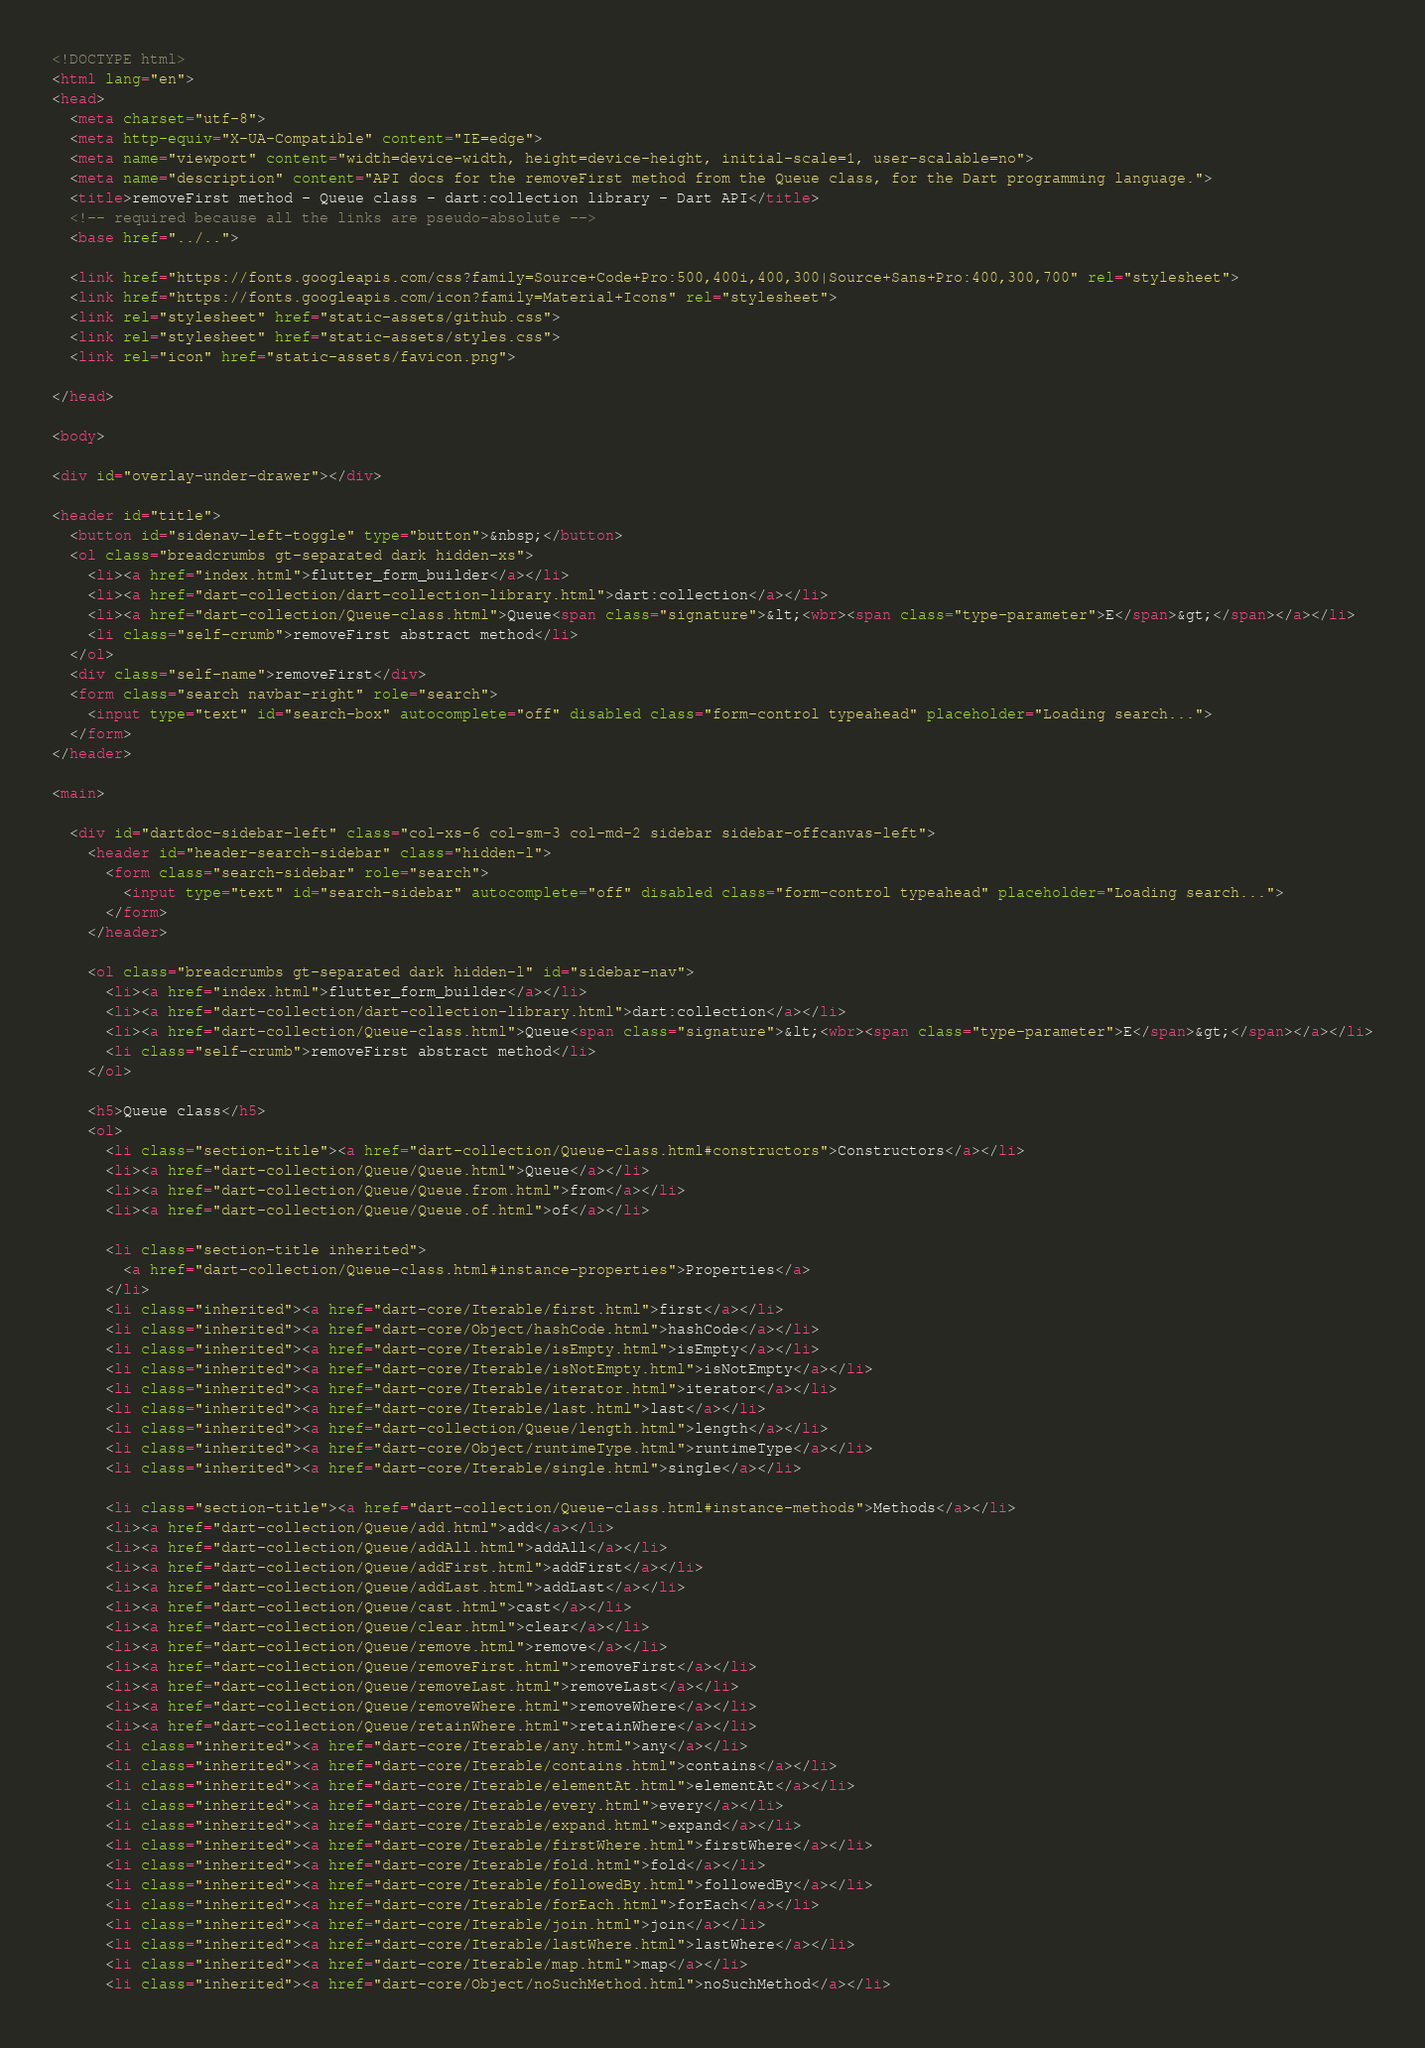Convert code to text. <code><loc_0><loc_0><loc_500><loc_500><_HTML_><!DOCTYPE html>
<html lang="en">
<head>
  <meta charset="utf-8">
  <meta http-equiv="X-UA-Compatible" content="IE=edge">
  <meta name="viewport" content="width=device-width, height=device-height, initial-scale=1, user-scalable=no">
  <meta name="description" content="API docs for the removeFirst method from the Queue class, for the Dart programming language.">
  <title>removeFirst method - Queue class - dart:collection library - Dart API</title>
  <!-- required because all the links are pseudo-absolute -->
  <base href="../..">

  <link href="https://fonts.googleapis.com/css?family=Source+Code+Pro:500,400i,400,300|Source+Sans+Pro:400,300,700" rel="stylesheet">
  <link href="https://fonts.googleapis.com/icon?family=Material+Icons" rel="stylesheet">
  <link rel="stylesheet" href="static-assets/github.css">
  <link rel="stylesheet" href="static-assets/styles.css">
  <link rel="icon" href="static-assets/favicon.png">
  
</head>

<body>

<div id="overlay-under-drawer"></div>

<header id="title">
  <button id="sidenav-left-toggle" type="button">&nbsp;</button>
  <ol class="breadcrumbs gt-separated dark hidden-xs">
    <li><a href="index.html">flutter_form_builder</a></li>
    <li><a href="dart-collection/dart-collection-library.html">dart:collection</a></li>
    <li><a href="dart-collection/Queue-class.html">Queue<span class="signature">&lt;<wbr><span class="type-parameter">E</span>&gt;</span></a></li>
    <li class="self-crumb">removeFirst abstract method</li>
  </ol>
  <div class="self-name">removeFirst</div>
  <form class="search navbar-right" role="search">
    <input type="text" id="search-box" autocomplete="off" disabled class="form-control typeahead" placeholder="Loading search...">
  </form>
</header>

<main>

  <div id="dartdoc-sidebar-left" class="col-xs-6 col-sm-3 col-md-2 sidebar sidebar-offcanvas-left">
    <header id="header-search-sidebar" class="hidden-l">
      <form class="search-sidebar" role="search">
        <input type="text" id="search-sidebar" autocomplete="off" disabled class="form-control typeahead" placeholder="Loading search...">
      </form>
    </header>
    
    <ol class="breadcrumbs gt-separated dark hidden-l" id="sidebar-nav">
      <li><a href="index.html">flutter_form_builder</a></li>
      <li><a href="dart-collection/dart-collection-library.html">dart:collection</a></li>
      <li><a href="dart-collection/Queue-class.html">Queue<span class="signature">&lt;<wbr><span class="type-parameter">E</span>&gt;</span></a></li>
      <li class="self-crumb">removeFirst abstract method</li>
    </ol>
    
    <h5>Queue class</h5>
    <ol>
      <li class="section-title"><a href="dart-collection/Queue-class.html#constructors">Constructors</a></li>
      <li><a href="dart-collection/Queue/Queue.html">Queue</a></li>
      <li><a href="dart-collection/Queue/Queue.from.html">from</a></li>
      <li><a href="dart-collection/Queue/Queue.of.html">of</a></li>
    
      <li class="section-title inherited">
        <a href="dart-collection/Queue-class.html#instance-properties">Properties</a>
      </li>
      <li class="inherited"><a href="dart-core/Iterable/first.html">first</a></li>
      <li class="inherited"><a href="dart-core/Object/hashCode.html">hashCode</a></li>
      <li class="inherited"><a href="dart-core/Iterable/isEmpty.html">isEmpty</a></li>
      <li class="inherited"><a href="dart-core/Iterable/isNotEmpty.html">isNotEmpty</a></li>
      <li class="inherited"><a href="dart-core/Iterable/iterator.html">iterator</a></li>
      <li class="inherited"><a href="dart-core/Iterable/last.html">last</a></li>
      <li class="inherited"><a href="dart-collection/Queue/length.html">length</a></li>
      <li class="inherited"><a href="dart-core/Object/runtimeType.html">runtimeType</a></li>
      <li class="inherited"><a href="dart-core/Iterable/single.html">single</a></li>
    
      <li class="section-title"><a href="dart-collection/Queue-class.html#instance-methods">Methods</a></li>
      <li><a href="dart-collection/Queue/add.html">add</a></li>
      <li><a href="dart-collection/Queue/addAll.html">addAll</a></li>
      <li><a href="dart-collection/Queue/addFirst.html">addFirst</a></li>
      <li><a href="dart-collection/Queue/addLast.html">addLast</a></li>
      <li><a href="dart-collection/Queue/cast.html">cast</a></li>
      <li><a href="dart-collection/Queue/clear.html">clear</a></li>
      <li><a href="dart-collection/Queue/remove.html">remove</a></li>
      <li><a href="dart-collection/Queue/removeFirst.html">removeFirst</a></li>
      <li><a href="dart-collection/Queue/removeLast.html">removeLast</a></li>
      <li><a href="dart-collection/Queue/removeWhere.html">removeWhere</a></li>
      <li><a href="dart-collection/Queue/retainWhere.html">retainWhere</a></li>
      <li class="inherited"><a href="dart-core/Iterable/any.html">any</a></li>
      <li class="inherited"><a href="dart-core/Iterable/contains.html">contains</a></li>
      <li class="inherited"><a href="dart-core/Iterable/elementAt.html">elementAt</a></li>
      <li class="inherited"><a href="dart-core/Iterable/every.html">every</a></li>
      <li class="inherited"><a href="dart-core/Iterable/expand.html">expand</a></li>
      <li class="inherited"><a href="dart-core/Iterable/firstWhere.html">firstWhere</a></li>
      <li class="inherited"><a href="dart-core/Iterable/fold.html">fold</a></li>
      <li class="inherited"><a href="dart-core/Iterable/followedBy.html">followedBy</a></li>
      <li class="inherited"><a href="dart-core/Iterable/forEach.html">forEach</a></li>
      <li class="inherited"><a href="dart-core/Iterable/join.html">join</a></li>
      <li class="inherited"><a href="dart-core/Iterable/lastWhere.html">lastWhere</a></li>
      <li class="inherited"><a href="dart-core/Iterable/map.html">map</a></li>
      <li class="inherited"><a href="dart-core/Object/noSuchMethod.html">noSuchMethod</a></li></code> 